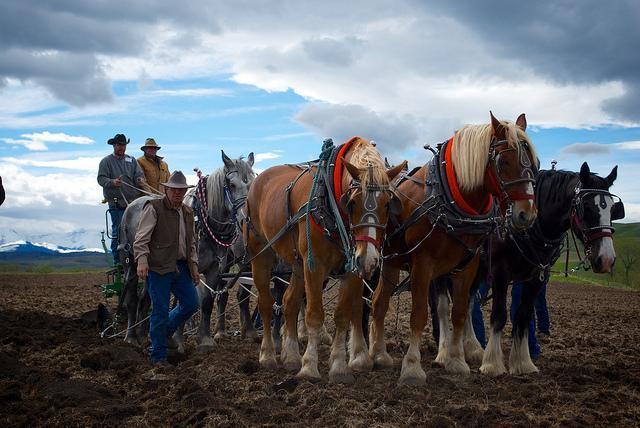How many horses are pictured?
Give a very brief answer. 4. How many horses are there?
Give a very brief answer. 4. How many people are there?
Give a very brief answer. 2. How many umbrellas are there?
Give a very brief answer. 0. 